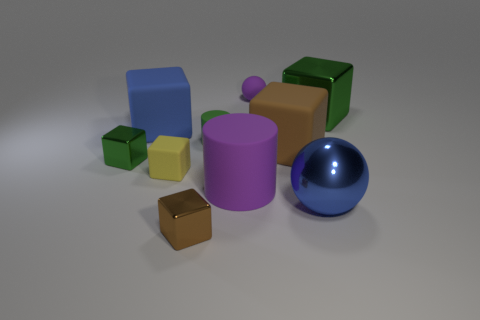Can you describe the lighting in the scene? The lighting in the scene is soft and diffused, casting gentle shadows primarily to the right of the objects, indicating a light source likely positioned to the upper left. 